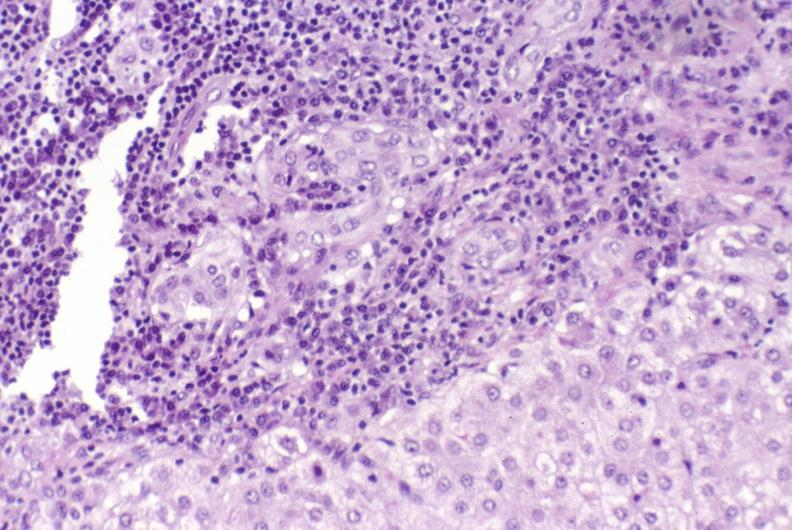s choanal patency present?
Answer the question using a single word or phrase. No 